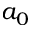Convert formula to latex. <formula><loc_0><loc_0><loc_500><loc_500>a _ { 0 }</formula> 